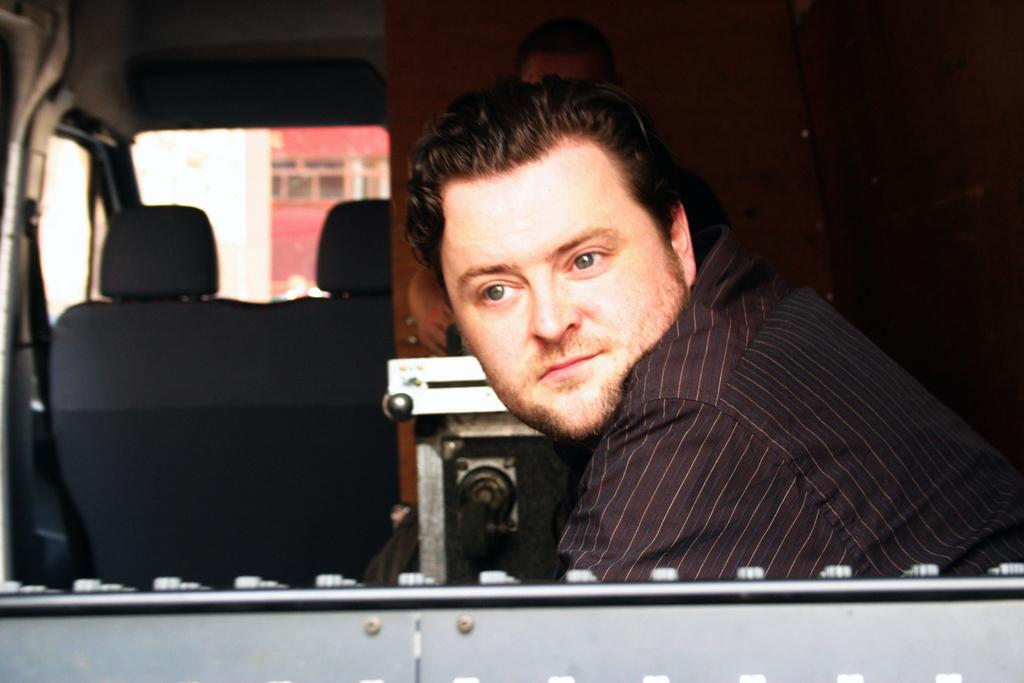What is the person in the image wearing? The person in the image is wearing a black shirt. Where is the person in the image located? The person is sitting in a car. Is there anyone else in the image with the person wearing a black shirt? Yes, there is another person beside the person wearing a black shirt. What type of teeth can be seen in the image? There are no teeth visible in the image, as it features a person sitting in a car and another person beside them. 